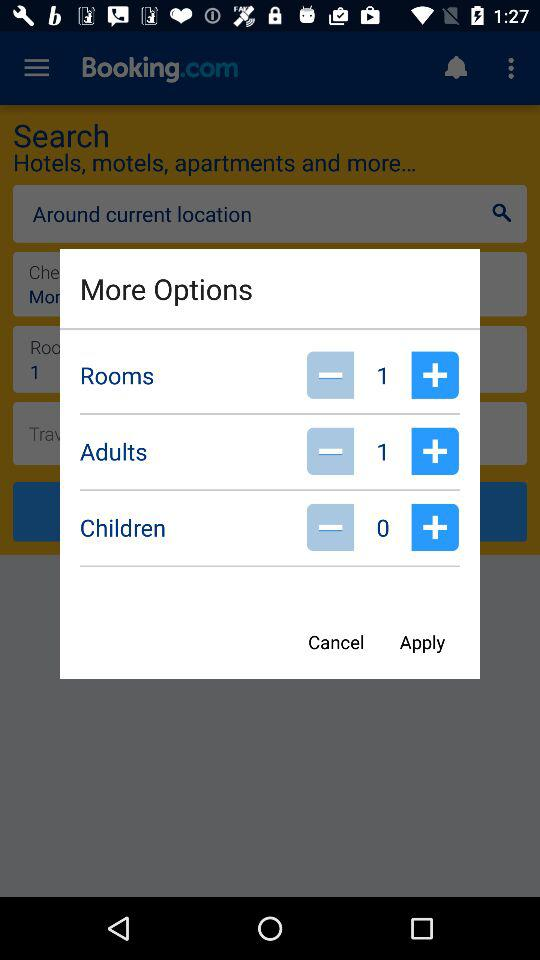How many adults are added? The added adult is 1. 